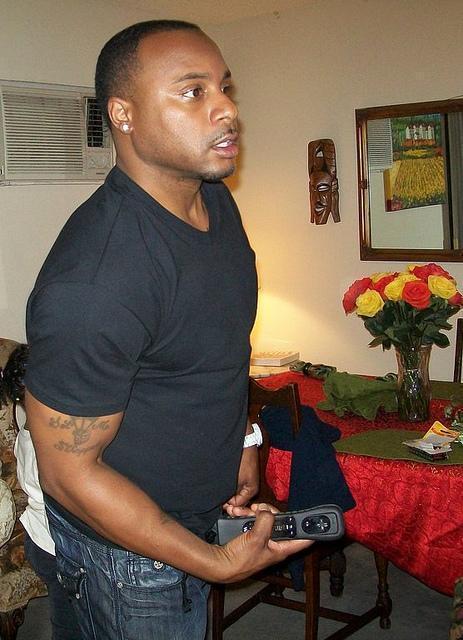The remote is meant to communicate with what?
Select the accurate response from the four choices given to answer the question.
Options: Telephone, computer, television, video game. Television. 